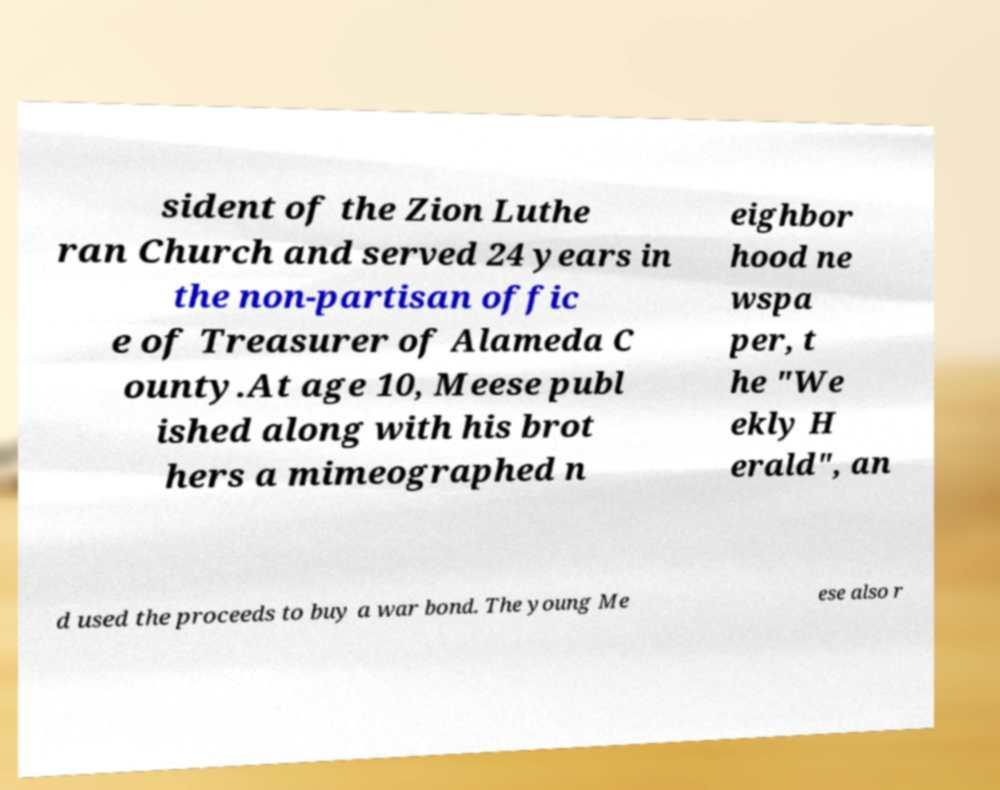For documentation purposes, I need the text within this image transcribed. Could you provide that? sident of the Zion Luthe ran Church and served 24 years in the non-partisan offic e of Treasurer of Alameda C ounty.At age 10, Meese publ ished along with his brot hers a mimeographed n eighbor hood ne wspa per, t he "We ekly H erald", an d used the proceeds to buy a war bond. The young Me ese also r 